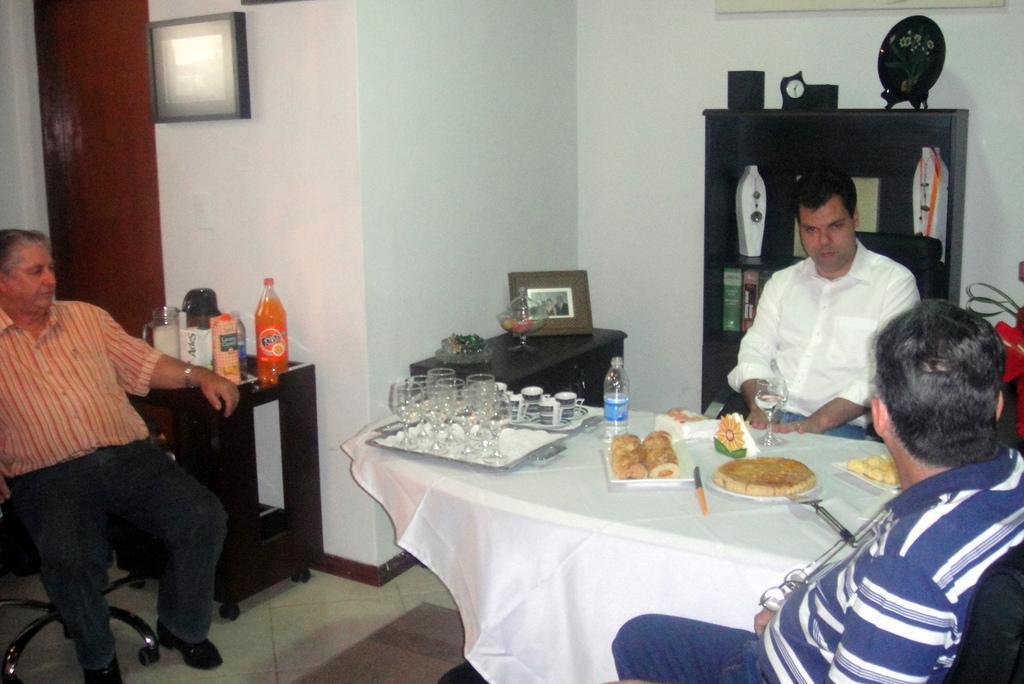Please provide a concise description of this image. There are three persons in this room. There are two tables. On the table having a white table sheet. On the table there are glasses, cups , trays, food items , bottle , knife. Another table there are bottles, photo frame. There is a cupboard. On the cup board there is a clock. In the background there is a wall. 